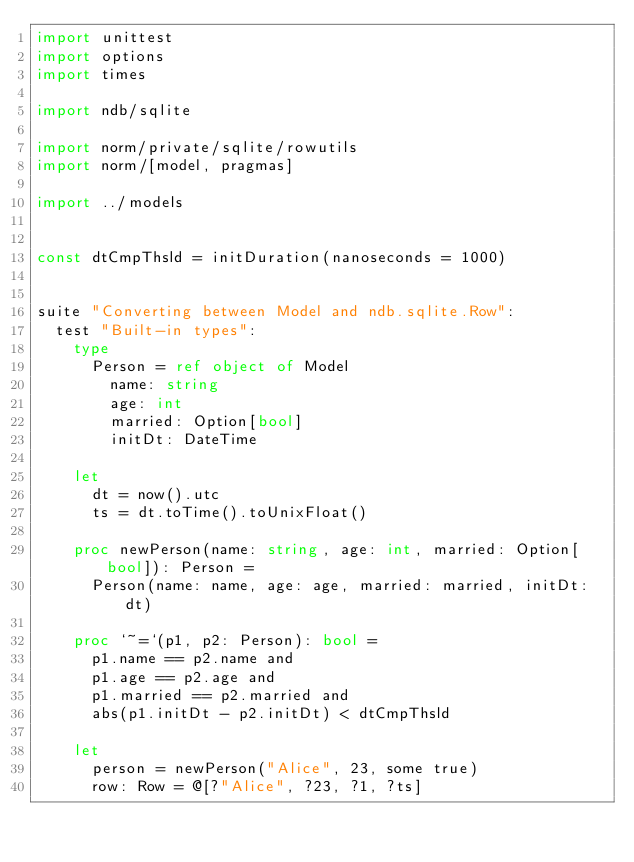<code> <loc_0><loc_0><loc_500><loc_500><_Nim_>import unittest
import options
import times

import ndb/sqlite

import norm/private/sqlite/rowutils
import norm/[model, pragmas]

import ../models


const dtCmpThsld = initDuration(nanoseconds = 1000)


suite "Converting between Model and ndb.sqlite.Row":
  test "Built-in types":
    type
      Person = ref object of Model
        name: string
        age: int
        married: Option[bool]
        initDt: DateTime

    let
      dt = now().utc
      ts = dt.toTime().toUnixFloat()

    proc newPerson(name: string, age: int, married: Option[bool]): Person =
      Person(name: name, age: age, married: married, initDt: dt)

    proc `~=`(p1, p2: Person): bool =
      p1.name == p2.name and
      p1.age == p2.age and
      p1.married == p2.married and
      abs(p1.initDt - p2.initDt) < dtCmpThsld

    let
      person = newPerson("Alice", 23, some true)
      row: Row = @[?"Alice", ?23, ?1, ?ts]</code> 